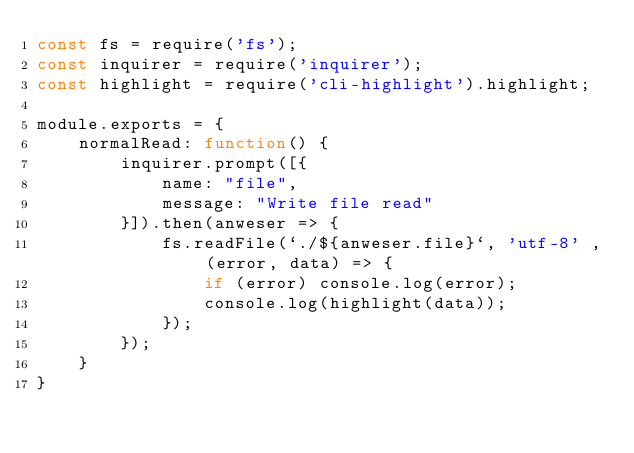Convert code to text. <code><loc_0><loc_0><loc_500><loc_500><_JavaScript_>const fs = require('fs');
const inquirer = require('inquirer');
const highlight = require('cli-highlight').highlight;

module.exports = {
    normalRead: function() {
        inquirer.prompt([{
            name: "file",
            message: "Write file read"
        }]).then(anweser => {
            fs.readFile(`./${anweser.file}`, 'utf-8' , (error, data) => {
                if (error) console.log(error);
                console.log(highlight(data));
            });
        });
    }
}</code> 